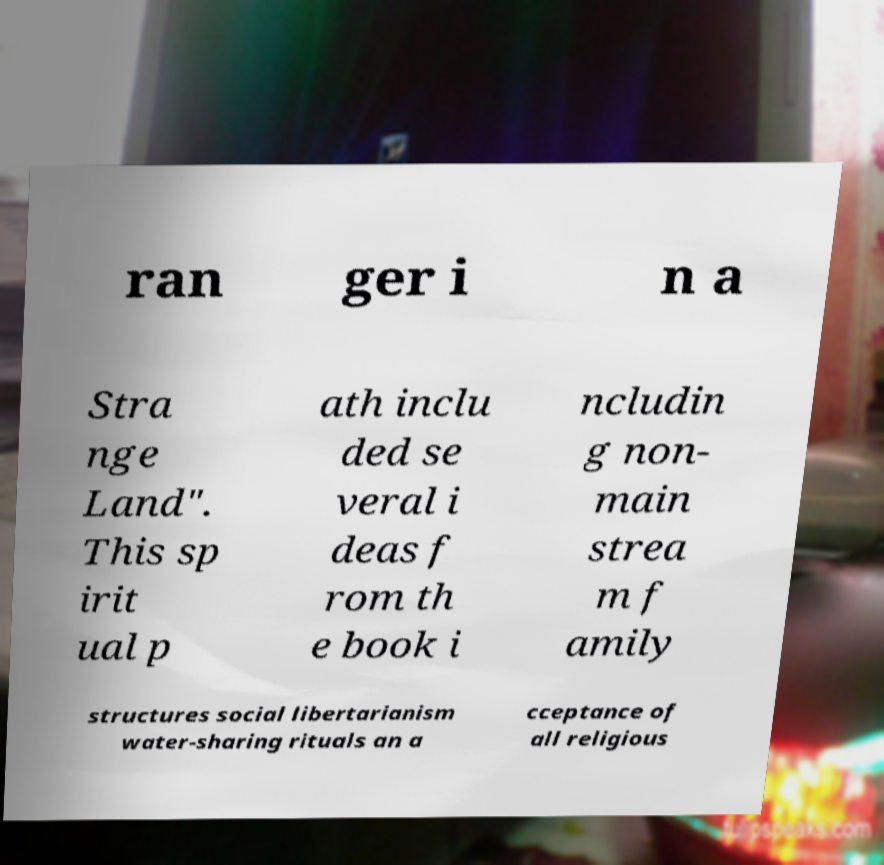Can you accurately transcribe the text from the provided image for me? ran ger i n a Stra nge Land". This sp irit ual p ath inclu ded se veral i deas f rom th e book i ncludin g non- main strea m f amily structures social libertarianism water-sharing rituals an a cceptance of all religious 